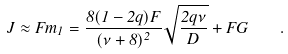<formula> <loc_0><loc_0><loc_500><loc_500>J \approx { F m _ { 1 } } = \frac { 8 ( 1 - 2 q ) F } { ( \nu + 8 ) ^ { 2 } } \sqrt { \frac { 2 q \nu } { D } } + F G \quad .</formula> 